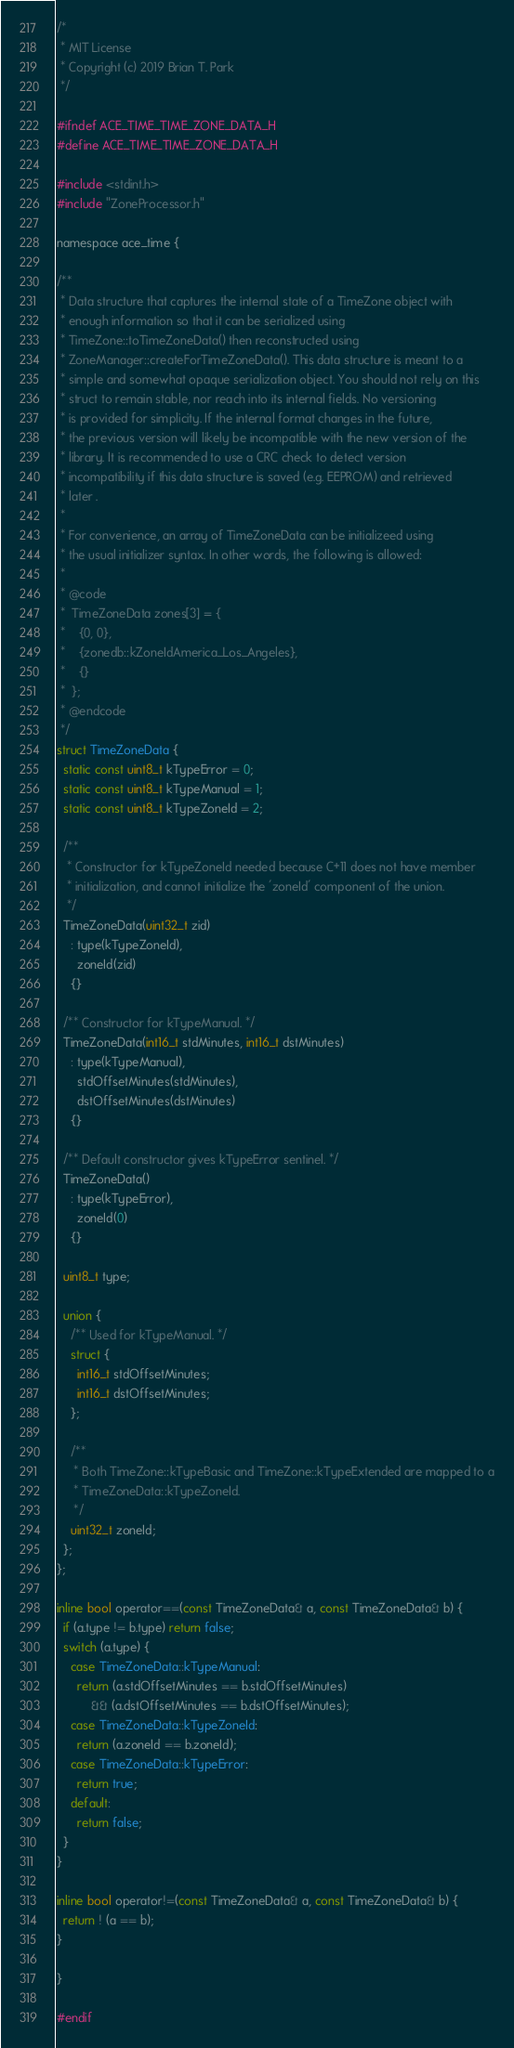<code> <loc_0><loc_0><loc_500><loc_500><_C_>/*
 * MIT License
 * Copyright (c) 2019 Brian T. Park
 */

#ifndef ACE_TIME_TIME_ZONE_DATA_H
#define ACE_TIME_TIME_ZONE_DATA_H

#include <stdint.h>
#include "ZoneProcessor.h"

namespace ace_time {

/**
 * Data structure that captures the internal state of a TimeZone object with
 * enough information so that it can be serialized using
 * TimeZone::toTimeZoneData() then reconstructed using
 * ZoneManager::createForTimeZoneData(). This data structure is meant to a
 * simple and somewhat opaque serialization object. You should not rely on this
 * struct to remain stable, nor reach into its internal fields. No versioning
 * is provided for simplicity. If the internal format changes in the future,
 * the previous version will likely be incompatible with the new version of the
 * library. It is recommended to use a CRC check to detect version
 * incompatibility if this data structure is saved (e.g. EEPROM) and retrieved
 * later .
 *
 * For convenience, an array of TimeZoneData can be initializeed using
 * the usual initializer syntax. In other words, the following is allowed:
 *
 * @code
 *  TimeZoneData zones[3] = {
 *    {0, 0},
 *    {zonedb::kZoneIdAmerica_Los_Angeles},
 *    {}
 *  };
 * @endcode
 */
struct TimeZoneData {
  static const uint8_t kTypeError = 0;
  static const uint8_t kTypeManual = 1;
  static const uint8_t kTypeZoneId = 2;

  /**
   * Constructor for kTypeZoneId needed because C+11 does not have member
   * initialization, and cannot initialize the 'zoneId' component of the union.
   */
  TimeZoneData(uint32_t zid)
    : type(kTypeZoneId),
      zoneId(zid)
    {}

  /** Constructor for kTypeManual. */
  TimeZoneData(int16_t stdMinutes, int16_t dstMinutes)
    : type(kTypeManual),
      stdOffsetMinutes(stdMinutes),
      dstOffsetMinutes(dstMinutes)
    {}

  /** Default constructor gives kTypeError sentinel. */
  TimeZoneData()
    : type(kTypeError),
      zoneId(0)
    {}

  uint8_t type;

  union {
    /** Used for kTypeManual. */
    struct {
      int16_t stdOffsetMinutes;
      int16_t dstOffsetMinutes;
    };

    /**
     * Both TimeZone::kTypeBasic and TimeZone::kTypeExtended are mapped to a
     * TimeZoneData::kTypeZoneId.
     */
    uint32_t zoneId;
  };
};

inline bool operator==(const TimeZoneData& a, const TimeZoneData& b) {
  if (a.type != b.type) return false;
  switch (a.type) {
    case TimeZoneData::kTypeManual:
      return (a.stdOffsetMinutes == b.stdOffsetMinutes)
          && (a.dstOffsetMinutes == b.dstOffsetMinutes);
    case TimeZoneData::kTypeZoneId:
      return (a.zoneId == b.zoneId);
    case TimeZoneData::kTypeError:
      return true;
    default:
      return false;
  }
}

inline bool operator!=(const TimeZoneData& a, const TimeZoneData& b) {
  return ! (a == b);
}

}

#endif
</code> 